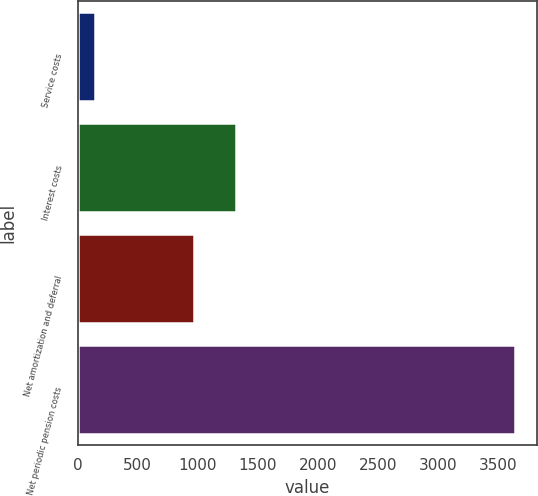<chart> <loc_0><loc_0><loc_500><loc_500><bar_chart><fcel>Service costs<fcel>Interest costs<fcel>Net amortization and deferral<fcel>Net periodic pension costs<nl><fcel>142<fcel>1316.4<fcel>967<fcel>3636<nl></chart> 